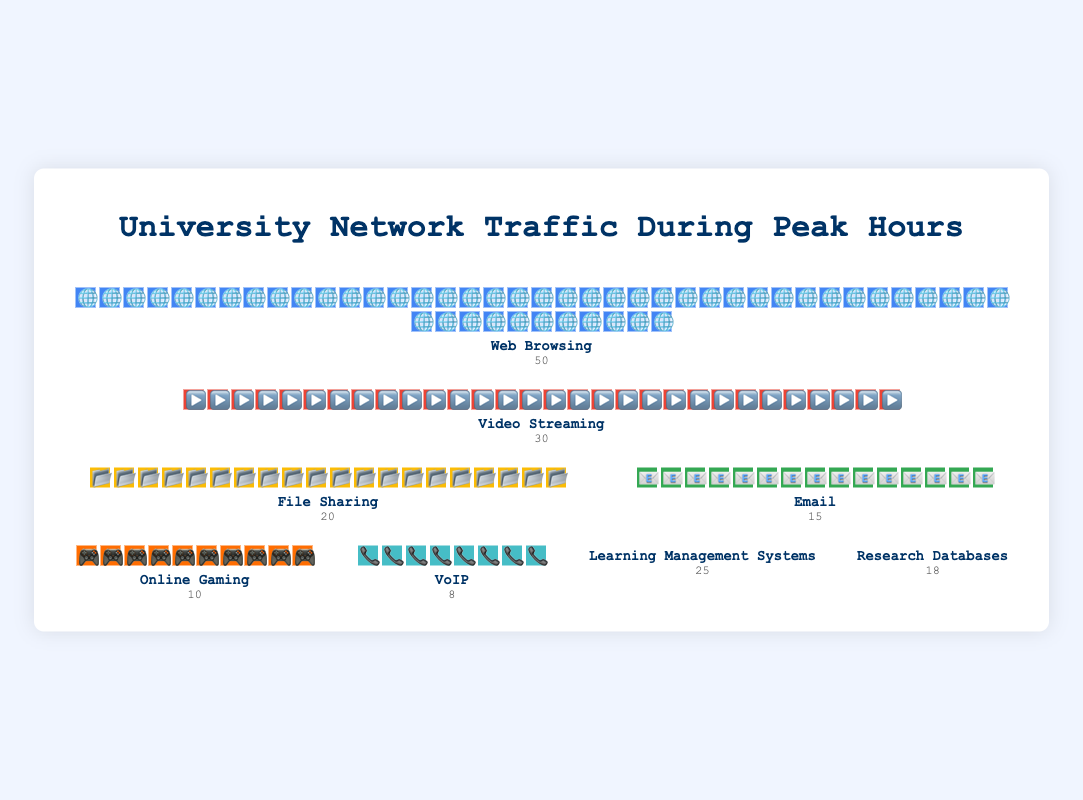What is the total number of data points shown in the figure? The figure depicts the number of data points by adding up the counts of all application types. Adding 50 for Web Browsing, 30 for Video Streaming, 20 for File Sharing, 15 for Email, 10 for Online Gaming, 8 for VoIP, 25 for Learning Management Systems, and 18 for Research Databases gives a total. 50 + 30 + 20 + 15 + 10 + 8 + 25 + 18 = 176
Answer: 176 Which application type has the highest network traffic? By visually inspecting the counts, Web Browsing has the highest value with 50 data points.
Answer: Web Browsing What is the total network traffic for educational purposes (Learning Management Systems and Research Databases)? Summing the counts for Learning Management Systems (25) and Research Databases (18): 25 + 18 = 43
Answer: 43 How does the network traffic for Video Streaming compare to Email? Video Streaming has a count of 30, while Email has a count of 15. 30 is greater than 15.
Answer: Video Streaming has more traffic than Email Which application type has the least network traffic, and what is its count? Visually comparing all counts, VoIP has the least network traffic with a count of 8.
Answer: VoIP, 8 What is the combined network traffic for leisure activities (Video Streaming, Online Gaming, and VoIP)? Adding the counts for Video Streaming (30), Online Gaming (10), and VoIP (8): 30 + 10 + 8 = 48
Answer: 48 How much more network traffic does Web Browsing generate compared to Online Gaming? Subtracting Online Gaming's count (10) from Web Browsing's count (50): 50 - 10 = 40
Answer: 40 By how much does the network traffic for File Sharing exceed Online Gaming? File Sharing has a count of 20, and Online Gaming has a count of 10. Subtracting these gives 20 - 10 = 10
Answer: 10 Which two application types together account for the highest network traffic? Comparing combinations, Web Browsing (50) and Video Streaming (30) together have the highest sum: 50 + 30 = 80
Answer: Web Browsing and Video Streaming What is the average network traffic for all application types? Summing all counts gives 176. There are 8 application types. Calculating the average: 176 / 8 = 22
Answer: 22 